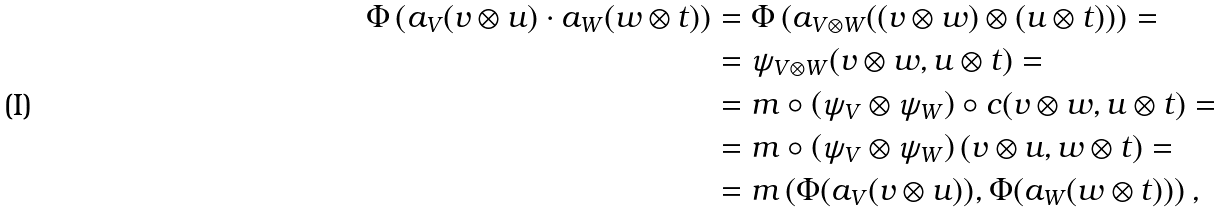<formula> <loc_0><loc_0><loc_500><loc_500>\Phi \left ( a _ { V } ( v \otimes u ) \cdot a _ { W } ( w \otimes t ) \right ) & = \Phi \left ( a _ { V \otimes W } ( ( v \otimes w ) \otimes ( u \otimes t ) ) \right ) = \\ & = \psi _ { V \otimes W } ( v \otimes w , u \otimes t ) = \\ & = m \circ \left ( \psi _ { V } \otimes \psi _ { W } \right ) \circ c ( v \otimes w , u \otimes t ) = \\ & = m \circ \left ( \psi _ { V } \otimes \psi _ { W } \right ) ( v \otimes u , w \otimes t ) = \\ & = m \left ( \Phi ( a _ { V } ( v \otimes u ) ) , \Phi ( a _ { W } ( w \otimes t ) ) \right ) ,</formula> 